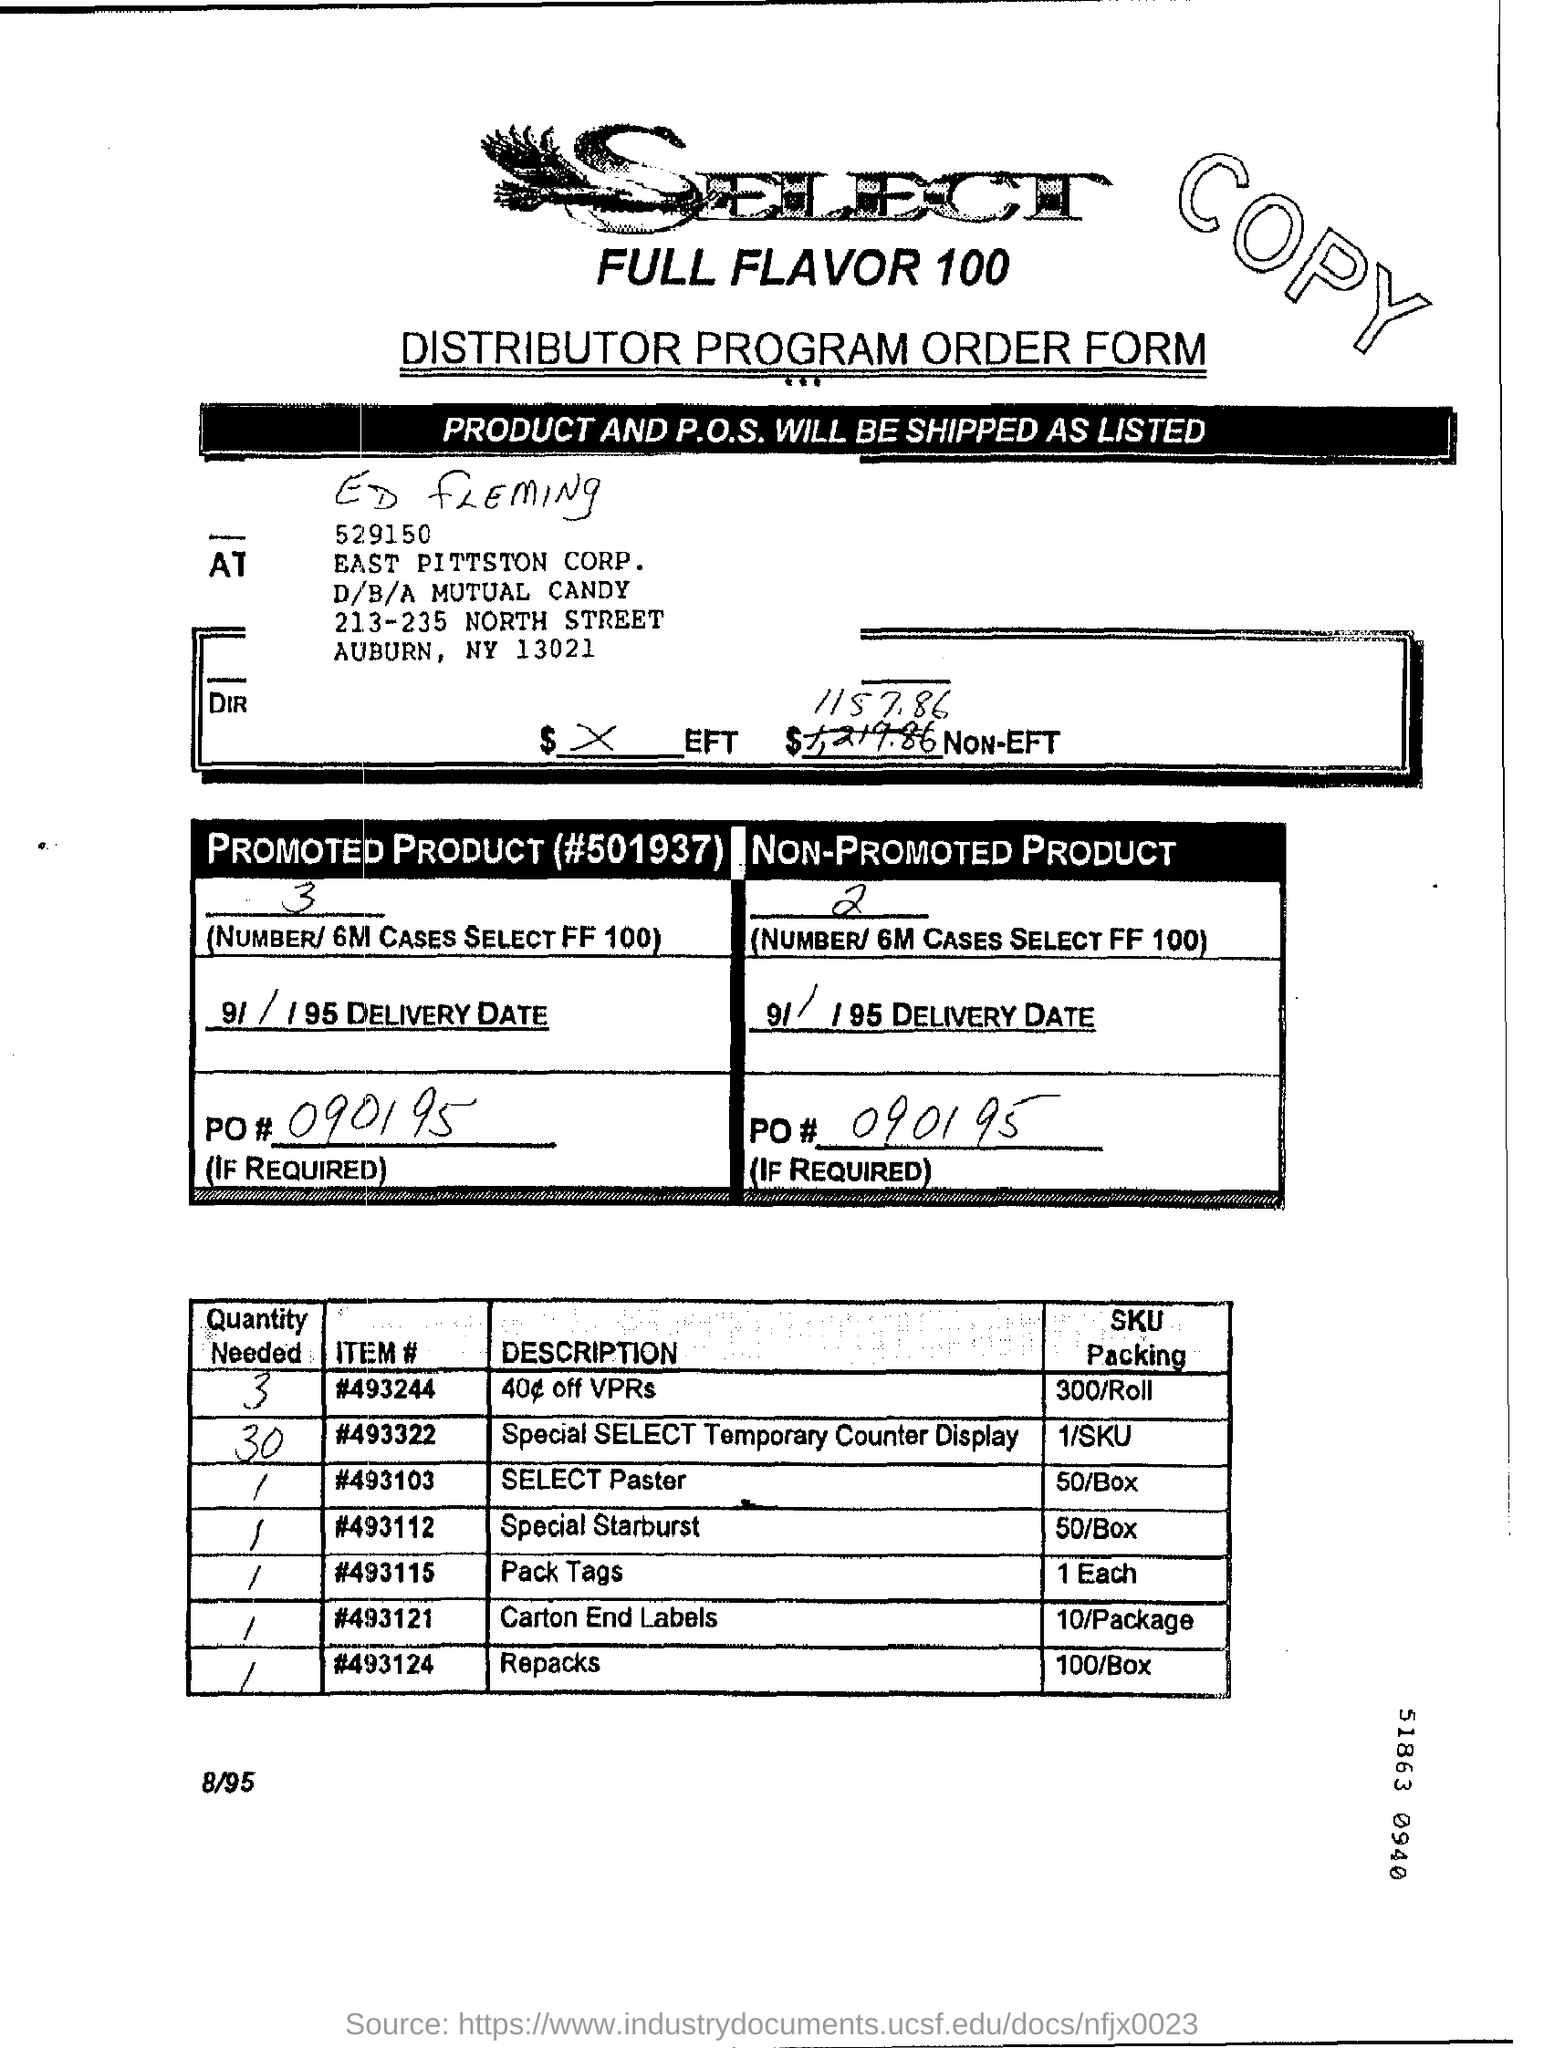What type of Order form is this ?
Ensure brevity in your answer.  Distributor Program Order Form. How many number of 'PROMOTED PRODUCT' based on first table?
Give a very brief answer. 3. What is the PO # given for "PROMOTED PRODUCT"?
Keep it short and to the point. 090195. Write the Item 'DESCRIPTION'  which is having highest quantity needed from table 2?
Offer a terse response. Special SELECT Temporary Counter Display. What is the maximum value written in 'Quantity Needed' column of table 2
Make the answer very short. 30. How much 'Quantity needed' for 'Repacks' based on second table?
Give a very brief answer. 1. How much is the "SKU Packing' for ITEM # 493121?
Keep it short and to the point. 10/Package. What is the " ITEM #" of "SELECT Paster" from second table?
Keep it short and to the point. 493103. How much Quantity is needed for 'ITEM' "#493244" based on second table?
Make the answer very short. 3. 